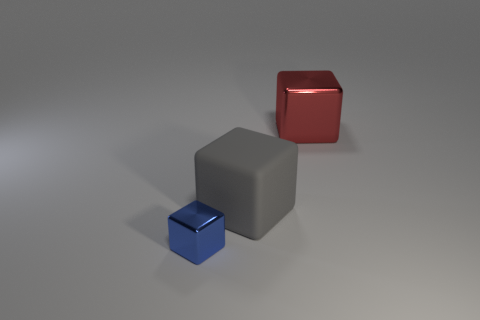Add 2 tiny blue objects. How many objects exist? 5 Subtract 0 gray spheres. How many objects are left? 3 Subtract all metal things. Subtract all big blue metal cylinders. How many objects are left? 1 Add 2 big shiny cubes. How many big shiny cubes are left? 3 Add 1 tiny cyan metal cubes. How many tiny cyan metal cubes exist? 1 